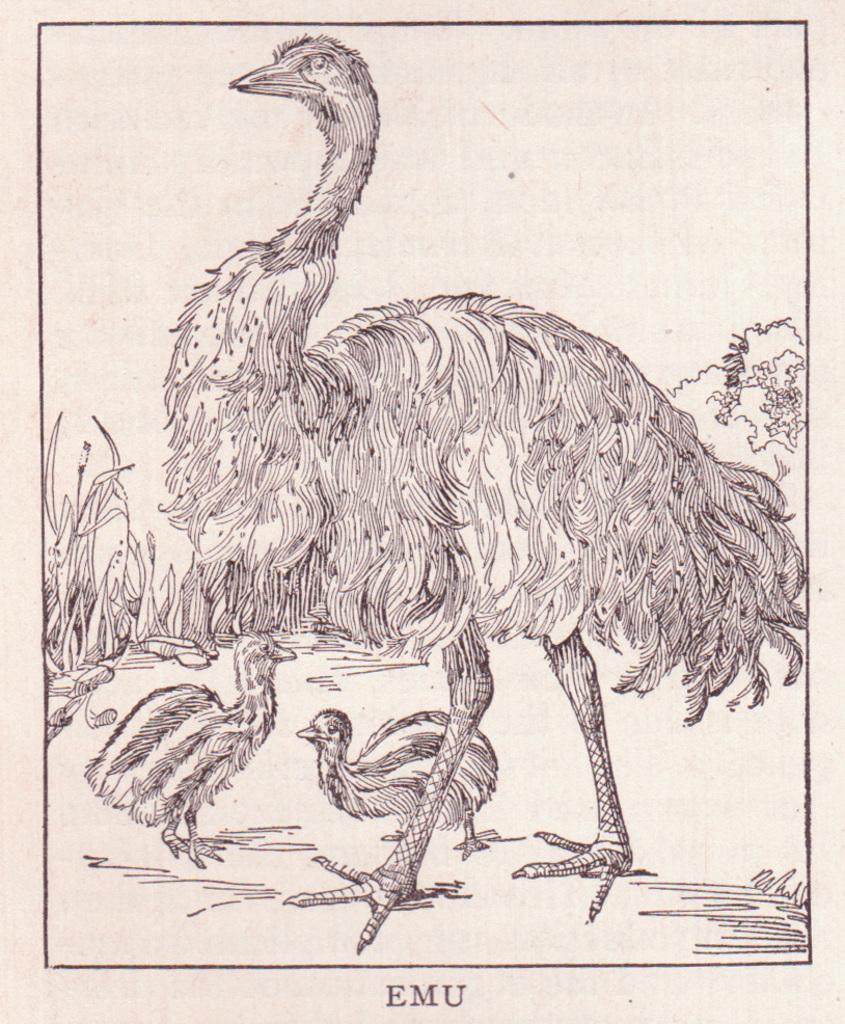What type of animals are depicted in the sketch in the image? The image contains a sketch of birds. What other elements are included in the sketch in the image? The image contains a sketch of trees. What color is the background of the image? The background of the image is white. How does the zinc react with the birds in the image? There is no zinc present in the image, so it cannot react with the birds. 